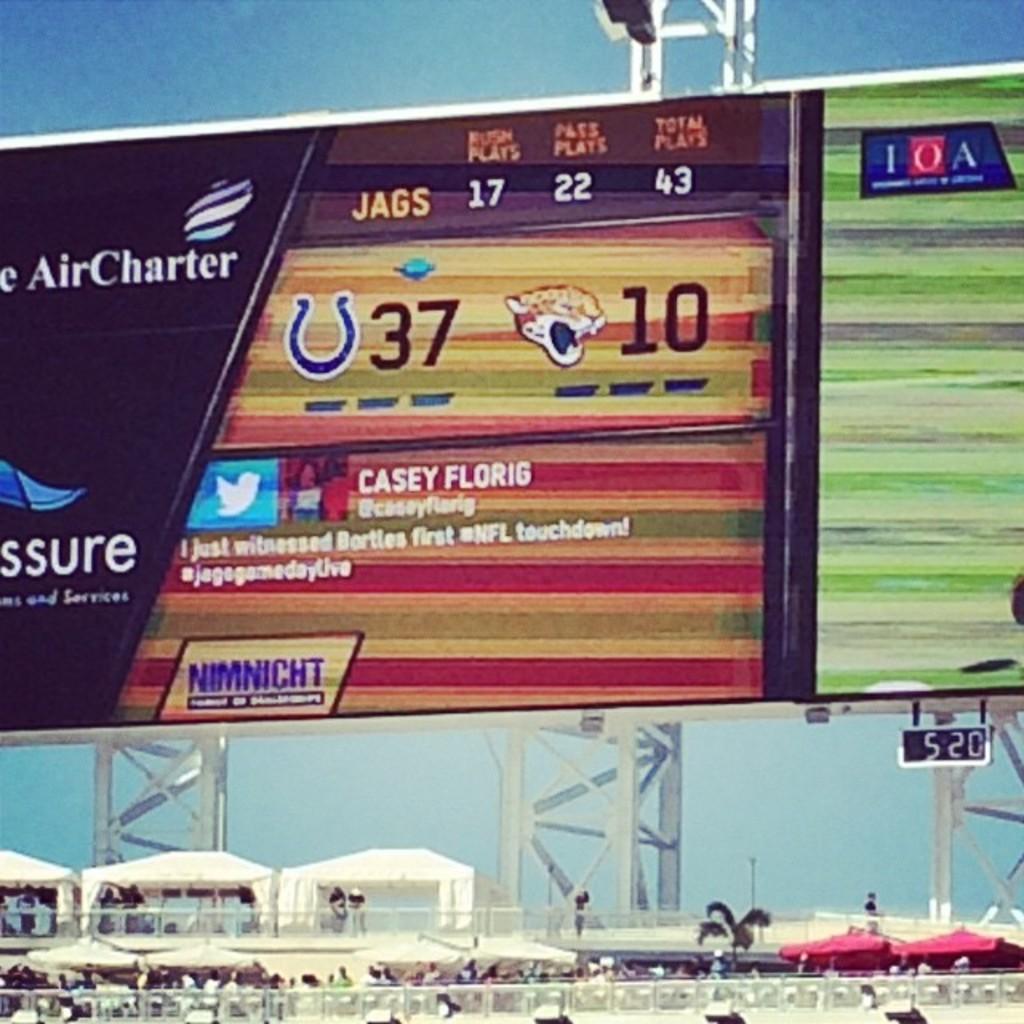What is the score?
Keep it short and to the point. 37 to 10. What is the team name who holds the 17, 22, 43 score?
Ensure brevity in your answer.  Jags. 